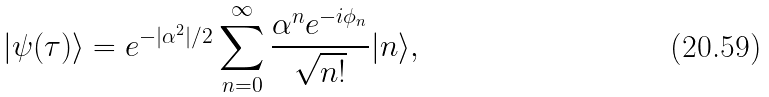Convert formula to latex. <formula><loc_0><loc_0><loc_500><loc_500>| \psi ( \tau ) \rangle = e ^ { - | \alpha ^ { 2 } | / 2 } \sum _ { n = 0 } ^ { \infty } \frac { \alpha ^ { n } e ^ { - i \phi _ { n } } } { \sqrt { n ! } } | n \rangle ,</formula> 